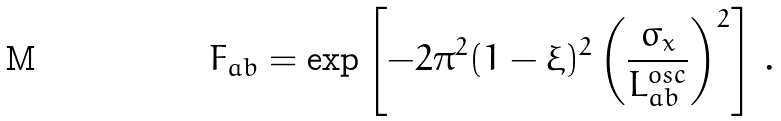Convert formula to latex. <formula><loc_0><loc_0><loc_500><loc_500>F _ { a b } = \exp \left [ - 2 \pi ^ { 2 } ( 1 - \xi ) ^ { 2 } \left ( \frac { \sigma _ { x } } { L _ { a b } ^ { o s c } } \right ) ^ { 2 } \right ] \, .</formula> 